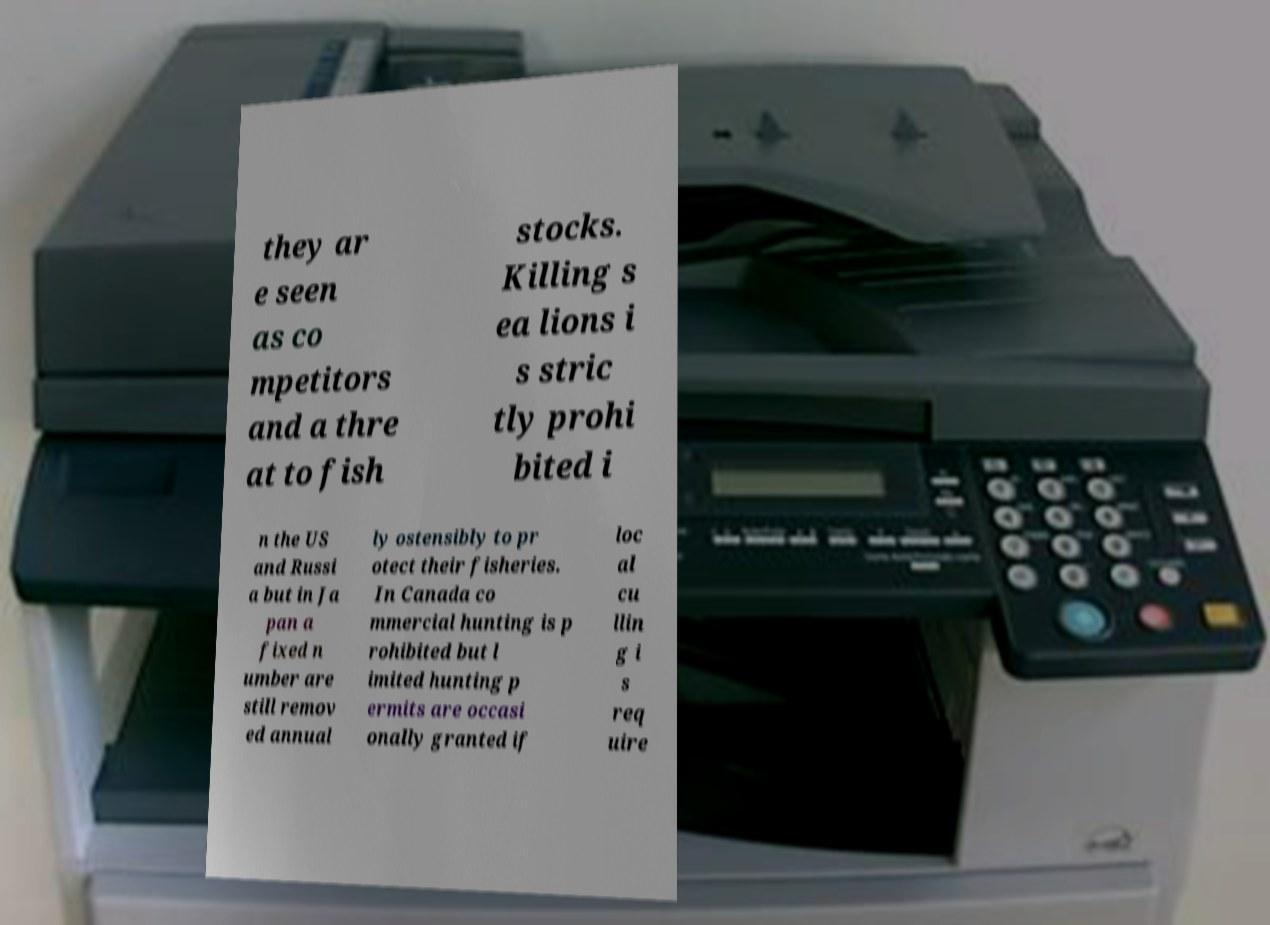Could you assist in decoding the text presented in this image and type it out clearly? they ar e seen as co mpetitors and a thre at to fish stocks. Killing s ea lions i s stric tly prohi bited i n the US and Russi a but in Ja pan a fixed n umber are still remov ed annual ly ostensibly to pr otect their fisheries. In Canada co mmercial hunting is p rohibited but l imited hunting p ermits are occasi onally granted if loc al cu llin g i s req uire 